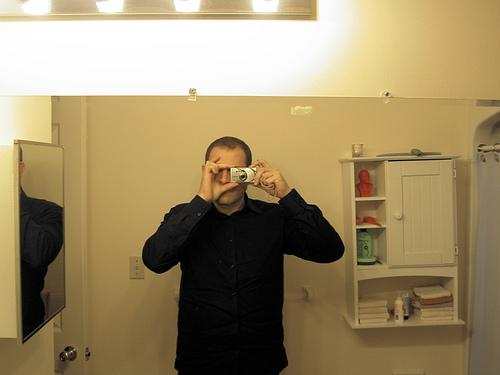What type of camera is he using?

Choices:
A) film
B) dslr
C) phone
D) digital digital 